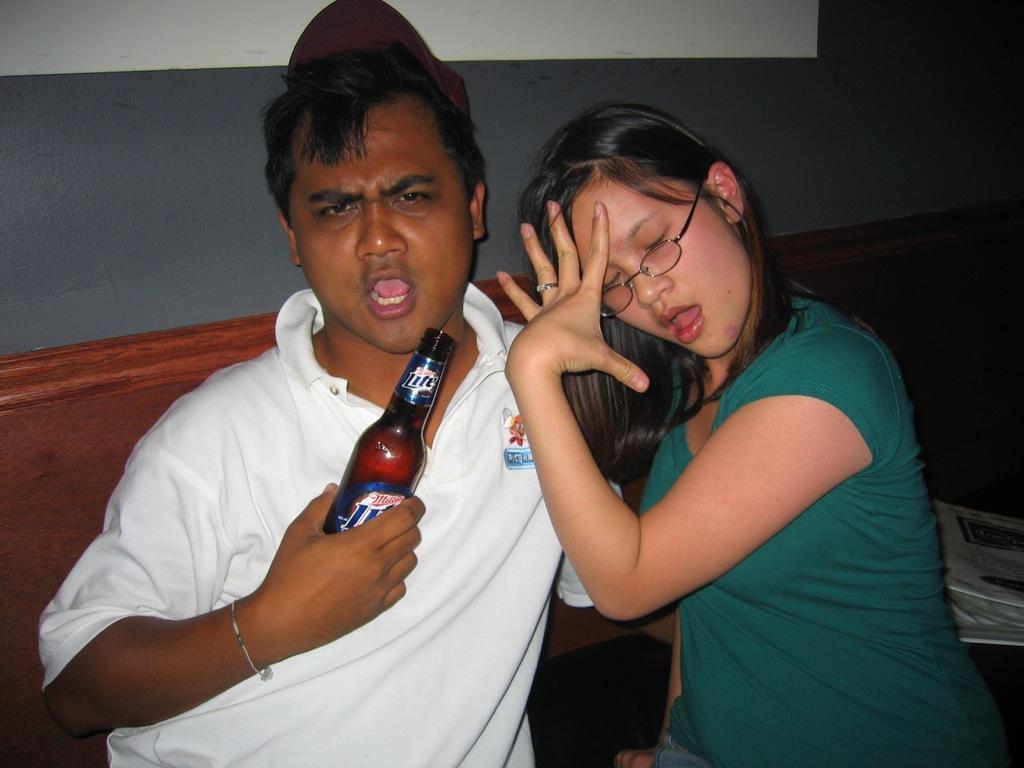Could you give a brief overview of what you see in this image? In this image i can see a man and a woman sitting, a man holding a bottle, at the back ground i can see a wall. 